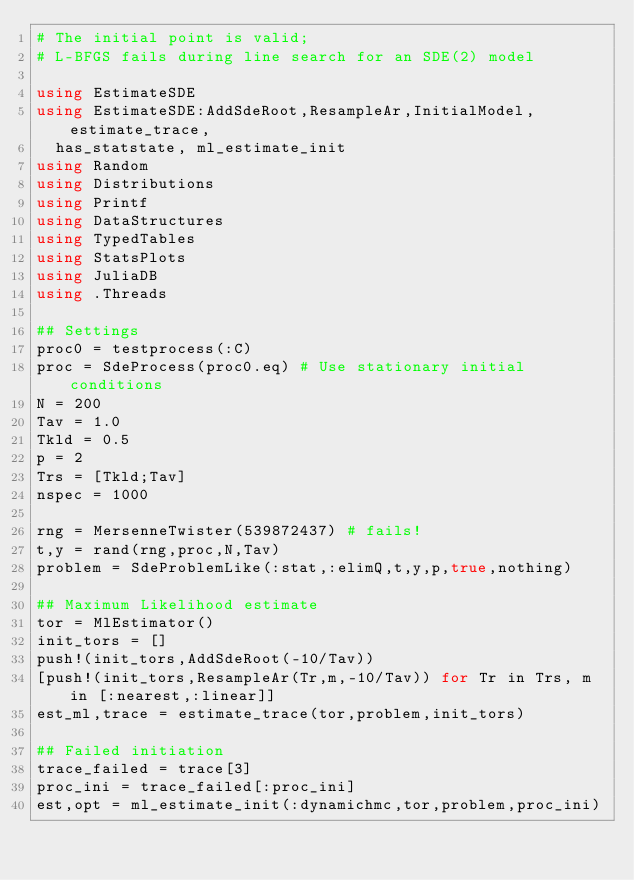Convert code to text. <code><loc_0><loc_0><loc_500><loc_500><_Julia_># The initial point is valid;
# L-BFGS fails during line search for an SDE(2) model

using EstimateSDE
using EstimateSDE:AddSdeRoot,ResampleAr,InitialModel,estimate_trace,
  has_statstate, ml_estimate_init
using Random
using Distributions
using Printf
using DataStructures
using TypedTables
using StatsPlots
using JuliaDB
using .Threads

## Settings
proc0 = testprocess(:C)
proc = SdeProcess(proc0.eq) # Use stationary initial conditions
N = 200
Tav = 1.0
Tkld = 0.5
p = 2
Trs = [Tkld;Tav]
nspec = 1000

rng = MersenneTwister(539872437) # fails!
t,y = rand(rng,proc,N,Tav)
problem = SdeProblemLike(:stat,:elimQ,t,y,p,true,nothing)

## Maximum Likelihood estimate
tor = MlEstimator()
init_tors = []
push!(init_tors,AddSdeRoot(-10/Tav))
[push!(init_tors,ResampleAr(Tr,m,-10/Tav)) for Tr in Trs, m in [:nearest,:linear]]
est_ml,trace = estimate_trace(tor,problem,init_tors)

## Failed initiation
trace_failed = trace[3]
proc_ini = trace_failed[:proc_ini]
est,opt = ml_estimate_init(:dynamichmc,tor,problem,proc_ini)
</code> 